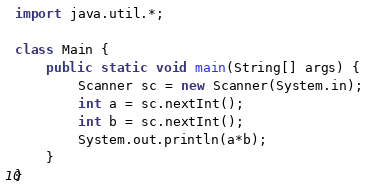Convert code to text. <code><loc_0><loc_0><loc_500><loc_500><_Java_>import java.util.*;

class Main {
    public static void main(String[] args) {
        Scanner sc = new Scanner(System.in);
        int a = sc.nextInt();
        int b = sc.nextInt();
        System.out.println(a*b);
    }
}</code> 